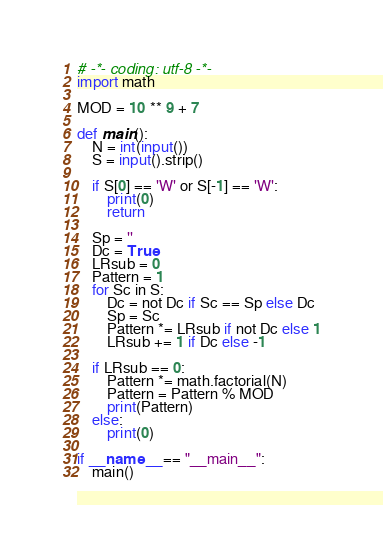Convert code to text. <code><loc_0><loc_0><loc_500><loc_500><_Python_># -*- coding: utf-8 -*-
import math

MOD = 10 ** 9 + 7

def main():
    N = int(input())
    S = input().strip()

    if S[0] == 'W' or S[-1] == 'W':
        print(0)
        return

    Sp = ''
    Dc = True
    LRsub = 0
    Pattern = 1
    for Sc in S:
        Dc = not Dc if Sc == Sp else Dc
        Sp = Sc
        Pattern *= LRsub if not Dc else 1
        LRsub += 1 if Dc else -1

    if LRsub == 0:
        Pattern *= math.factorial(N)
        Pattern = Pattern % MOD
        print(Pattern)
    else:
        print(0)

if __name__ == "__main__":
    main()
</code> 